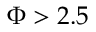<formula> <loc_0><loc_0><loc_500><loc_500>\Phi > 2 . 5</formula> 